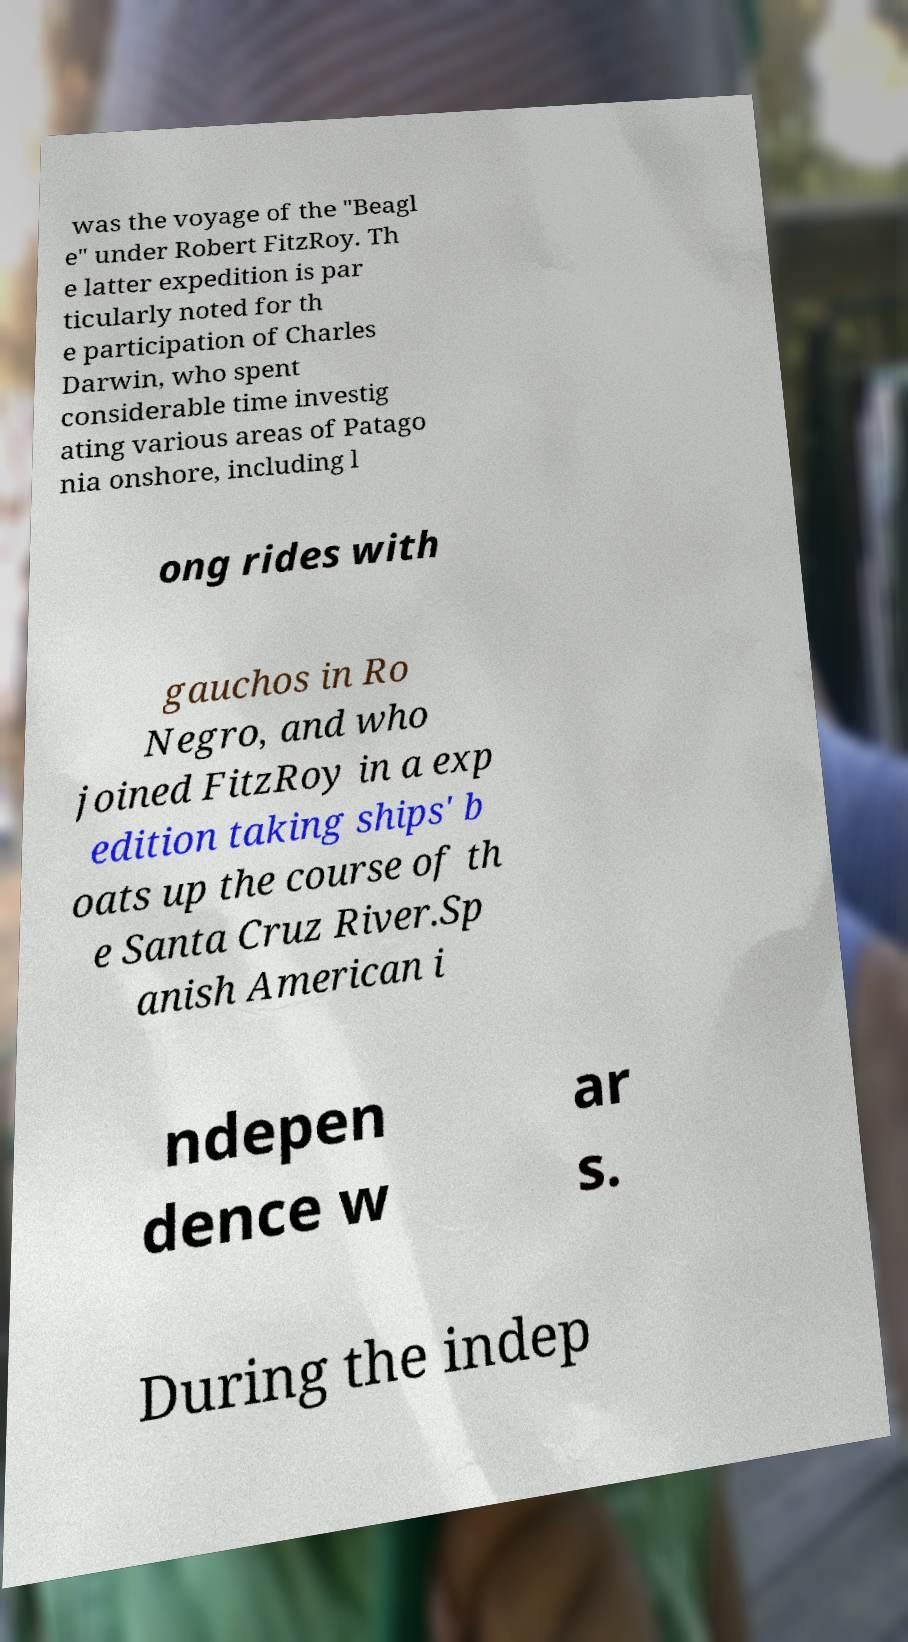There's text embedded in this image that I need extracted. Can you transcribe it verbatim? was the voyage of the "Beagl e" under Robert FitzRoy. Th e latter expedition is par ticularly noted for th e participation of Charles Darwin, who spent considerable time investig ating various areas of Patago nia onshore, including l ong rides with gauchos in Ro Negro, and who joined FitzRoy in a exp edition taking ships' b oats up the course of th e Santa Cruz River.Sp anish American i ndepen dence w ar s. During the indep 